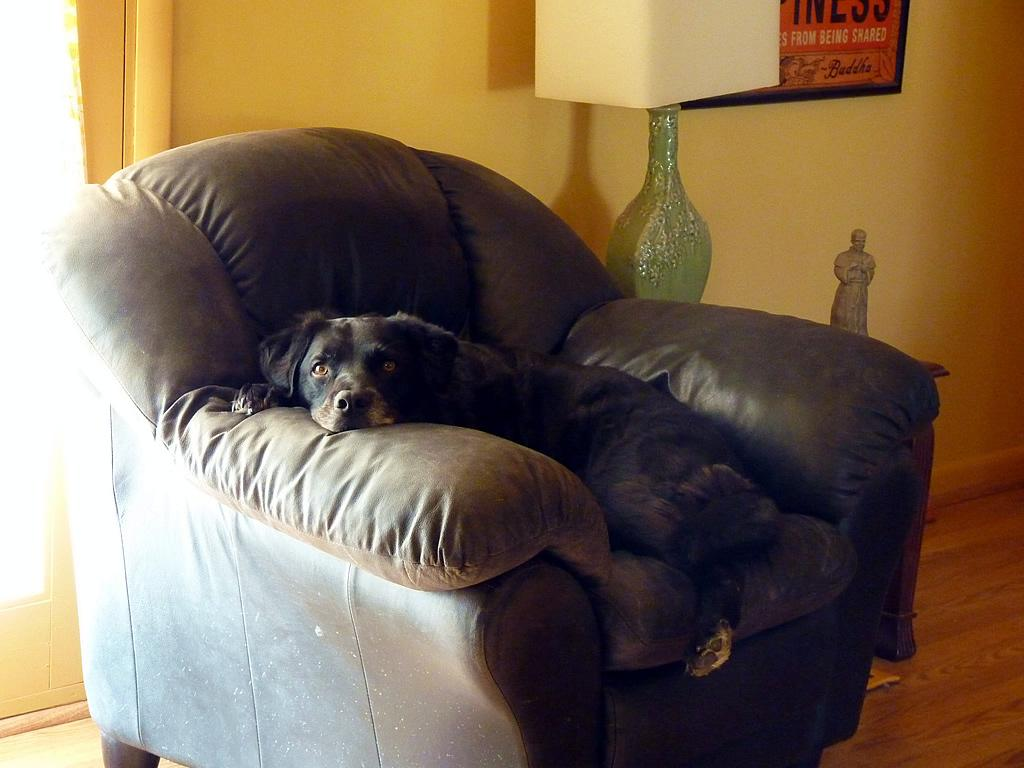What type of furniture is in the image? There is a black sofa in the image. What is on the black sofa? A dog is on the black sofa. What color is the dog? The dog is also black. What other object can be seen in the image? There is a lamp in the image. Where is the lamp located? The lamp is on top of something, likely the sofa or a table. What is on the wall in the image? There is a photo frame on the wall. What type of cake is on the level in the bedroom? There is no cake or level present in the image; it features a black sofa with a black dog, a lamp, and a photo frame on the wall. 